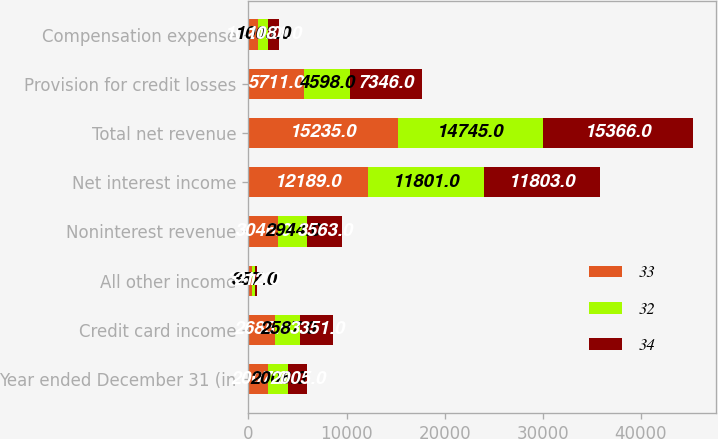Convert chart. <chart><loc_0><loc_0><loc_500><loc_500><stacked_bar_chart><ecel><fcel>Year ended December 31 (in<fcel>Credit card income<fcel>All other income<fcel>Noninterest revenue<fcel>Net interest income<fcel>Total net revenue<fcel>Provision for credit losses<fcel>Compensation expense<nl><fcel>33<fcel>2007<fcel>2685<fcel>361<fcel>3046<fcel>12189<fcel>15235<fcel>5711<fcel>1021<nl><fcel>32<fcel>2006<fcel>2587<fcel>357<fcel>2944<fcel>11801<fcel>14745<fcel>4598<fcel>1003<nl><fcel>34<fcel>2005<fcel>3351<fcel>212<fcel>3563<fcel>11803<fcel>15366<fcel>7346<fcel>1081<nl></chart> 